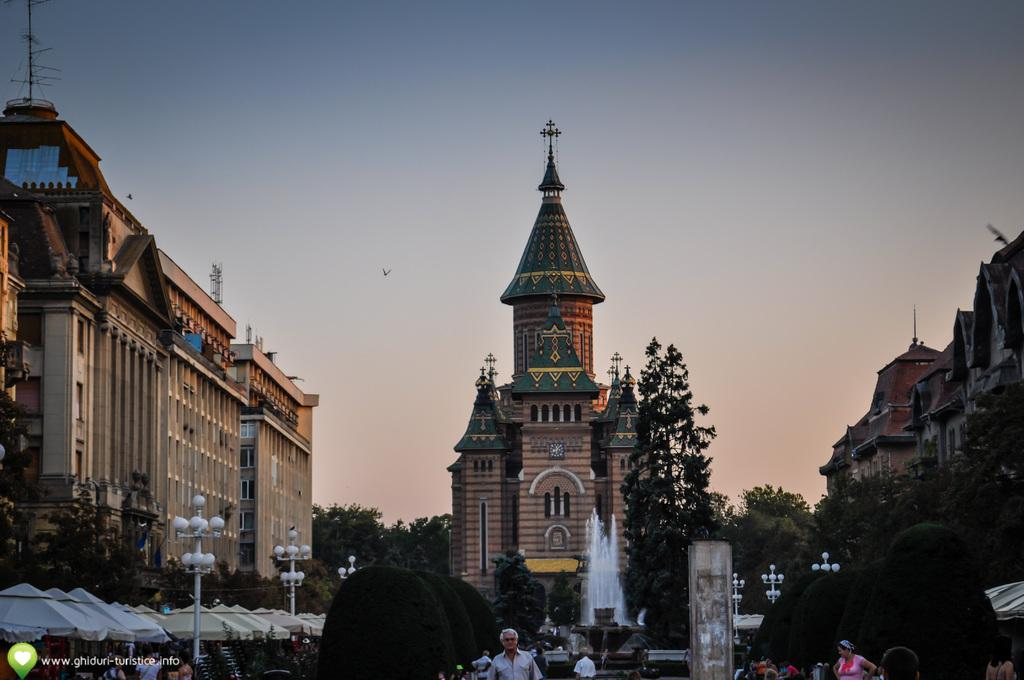What are the people in the image doing? The people in the image are walking. What type of structures can be seen in the image? There are lamp posts, fountains, tents, bushes, and buildings in the image. What type of vegetation is present in the image? There are trees in the image. What can be found at the bottom of the image? There is text at the bottom of the image. What type of rail can be seen in the image? There is no rail present in the image. What discovery was made by the people walking in the image? The image does not depict any specific discovery made by the people walking; they are simply walking. 